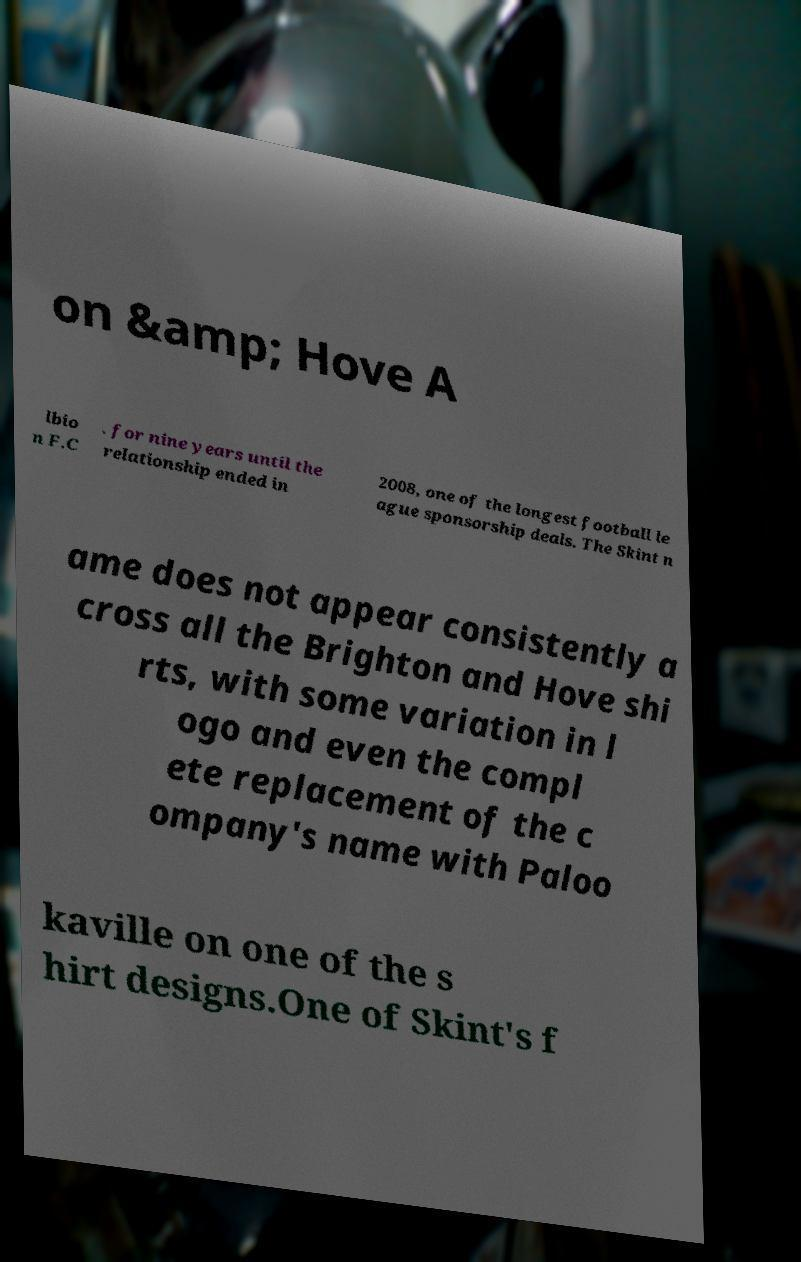I need the written content from this picture converted into text. Can you do that? on &amp; Hove A lbio n F.C . for nine years until the relationship ended in 2008, one of the longest football le ague sponsorship deals. The Skint n ame does not appear consistently a cross all the Brighton and Hove shi rts, with some variation in l ogo and even the compl ete replacement of the c ompany's name with Paloo kaville on one of the s hirt designs.One of Skint's f 